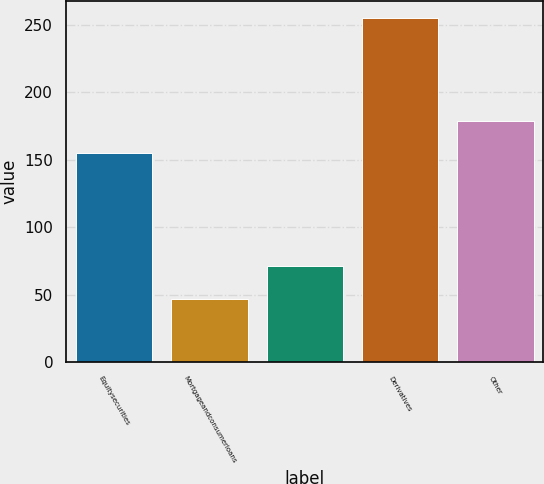<chart> <loc_0><loc_0><loc_500><loc_500><bar_chart><fcel>Equitysecurities<fcel>Mortgageandconsumerloans<fcel>Unnamed: 2<fcel>Derivatives<fcel>Other<nl><fcel>155<fcel>47<fcel>70.9<fcel>255<fcel>178.9<nl></chart> 